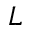<formula> <loc_0><loc_0><loc_500><loc_500>L</formula> 